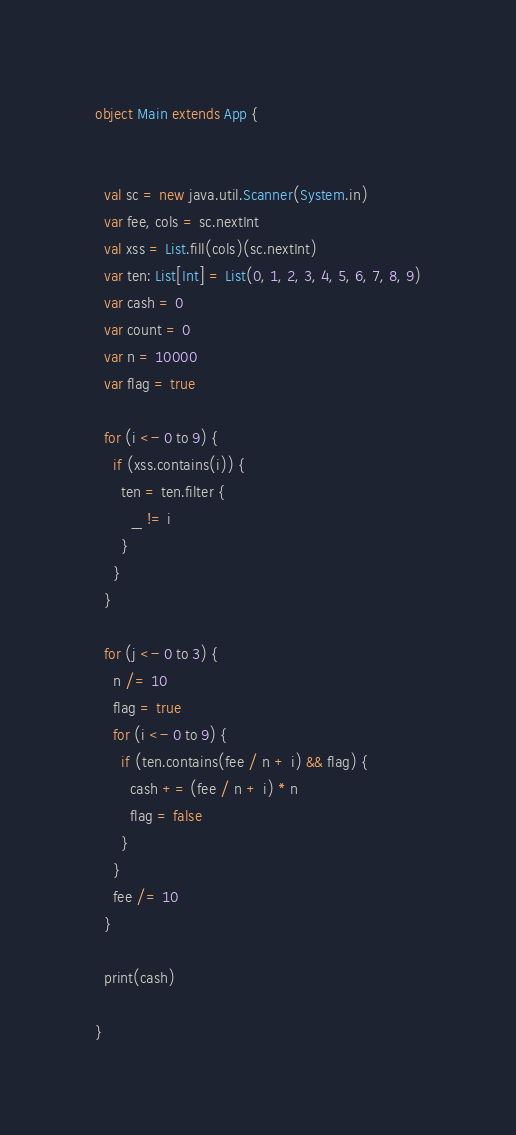<code> <loc_0><loc_0><loc_500><loc_500><_Scala_>object Main extends App {


  val sc = new java.util.Scanner(System.in)
  var fee, cols = sc.nextInt
  val xss = List.fill(cols)(sc.nextInt)
  var ten: List[Int] = List(0, 1, 2, 3, 4, 5, 6, 7, 8, 9)
  var cash = 0
  var count = 0
  var n = 10000
  var flag = true

  for (i <- 0 to 9) {
    if (xss.contains(i)) {
      ten = ten.filter {
        _ != i
      }
    }
  }

  for (j <- 0 to 3) {
    n /= 10
    flag = true
    for (i <- 0 to 9) {
      if (ten.contains(fee / n + i) && flag) {
        cash += (fee / n + i) * n
        flag = false
      }
    }
    fee /= 10
  }

  print(cash)

}
</code> 